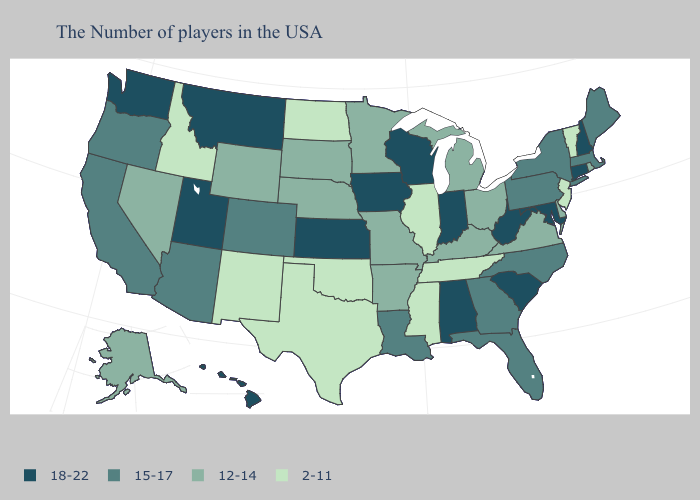What is the value of Florida?
Concise answer only. 15-17. Name the states that have a value in the range 18-22?
Write a very short answer. New Hampshire, Connecticut, Maryland, South Carolina, West Virginia, Indiana, Alabama, Wisconsin, Iowa, Kansas, Utah, Montana, Washington, Hawaii. Does South Carolina have the same value as Delaware?
Keep it brief. No. Which states have the lowest value in the USA?
Answer briefly. Vermont, New Jersey, Tennessee, Illinois, Mississippi, Oklahoma, Texas, North Dakota, New Mexico, Idaho. Does Montana have the highest value in the USA?
Give a very brief answer. Yes. What is the lowest value in the MidWest?
Answer briefly. 2-11. Which states hav the highest value in the South?
Quick response, please. Maryland, South Carolina, West Virginia, Alabama. Is the legend a continuous bar?
Be succinct. No. Is the legend a continuous bar?
Keep it brief. No. What is the lowest value in the USA?
Keep it brief. 2-11. Which states have the lowest value in the USA?
Answer briefly. Vermont, New Jersey, Tennessee, Illinois, Mississippi, Oklahoma, Texas, North Dakota, New Mexico, Idaho. What is the highest value in the USA?
Write a very short answer. 18-22. Does Michigan have the highest value in the MidWest?
Answer briefly. No. Name the states that have a value in the range 15-17?
Keep it brief. Maine, Massachusetts, New York, Pennsylvania, North Carolina, Florida, Georgia, Louisiana, Colorado, Arizona, California, Oregon. Does the map have missing data?
Quick response, please. No. 